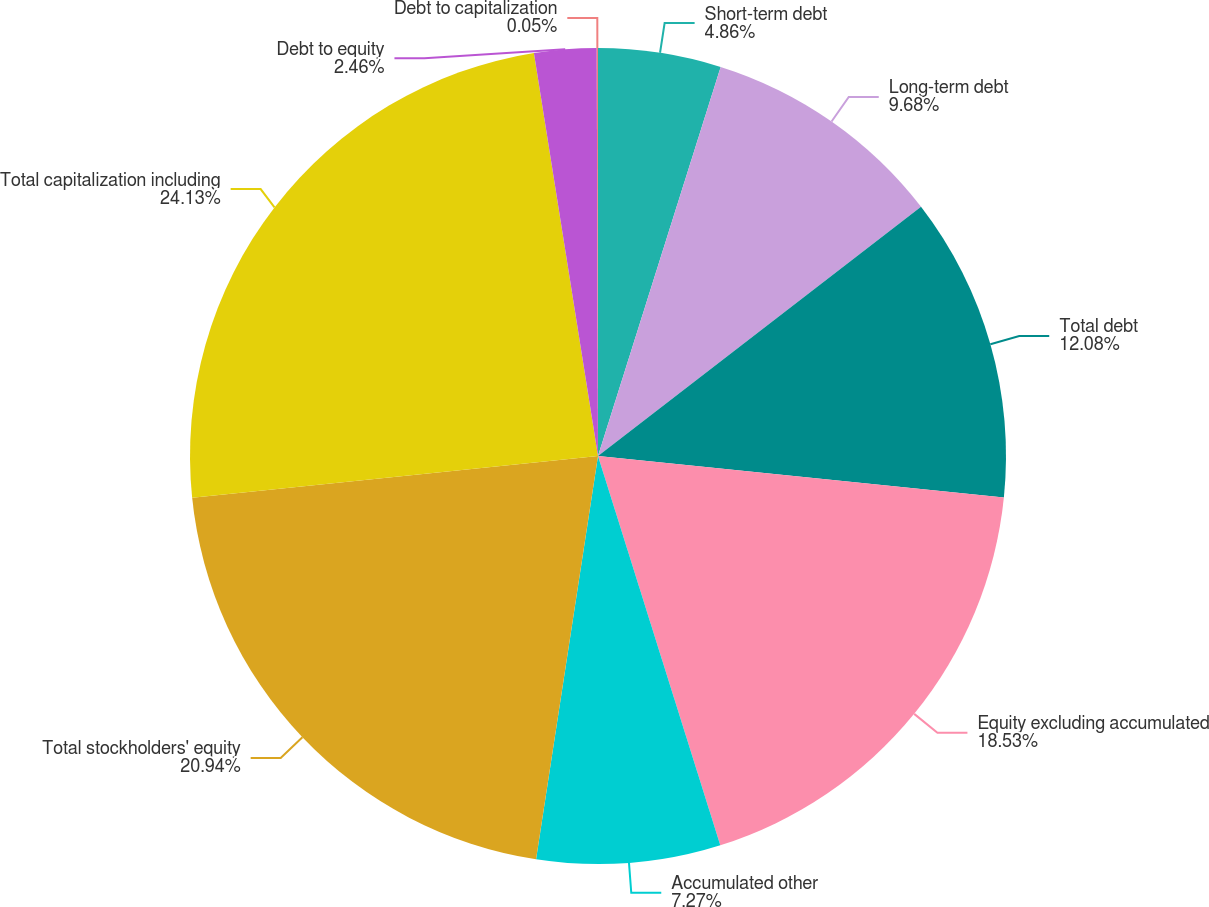Convert chart to OTSL. <chart><loc_0><loc_0><loc_500><loc_500><pie_chart><fcel>Short-term debt<fcel>Long-term debt<fcel>Total debt<fcel>Equity excluding accumulated<fcel>Accumulated other<fcel>Total stockholders' equity<fcel>Total capitalization including<fcel>Debt to equity<fcel>Debt to capitalization<nl><fcel>4.86%<fcel>9.68%<fcel>12.08%<fcel>18.53%<fcel>7.27%<fcel>20.94%<fcel>24.12%<fcel>2.46%<fcel>0.05%<nl></chart> 